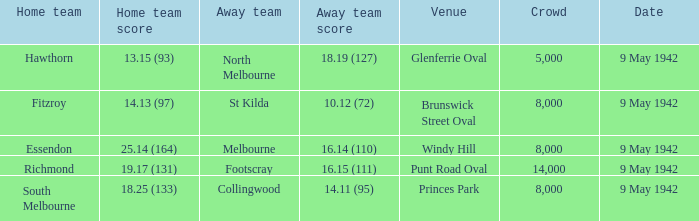How many individuals were present at the match where footscray was visiting? 14000.0. 